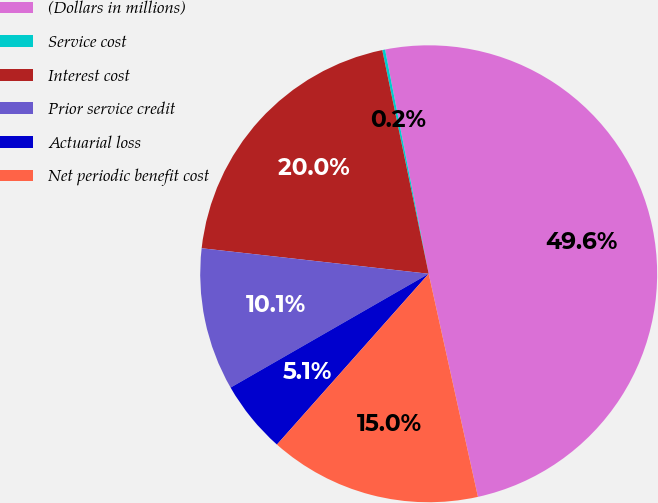Convert chart to OTSL. <chart><loc_0><loc_0><loc_500><loc_500><pie_chart><fcel>(Dollars in millions)<fcel>Service cost<fcel>Interest cost<fcel>Prior service credit<fcel>Actuarial loss<fcel>Net periodic benefit cost<nl><fcel>49.6%<fcel>0.2%<fcel>19.96%<fcel>10.08%<fcel>5.14%<fcel>15.02%<nl></chart> 